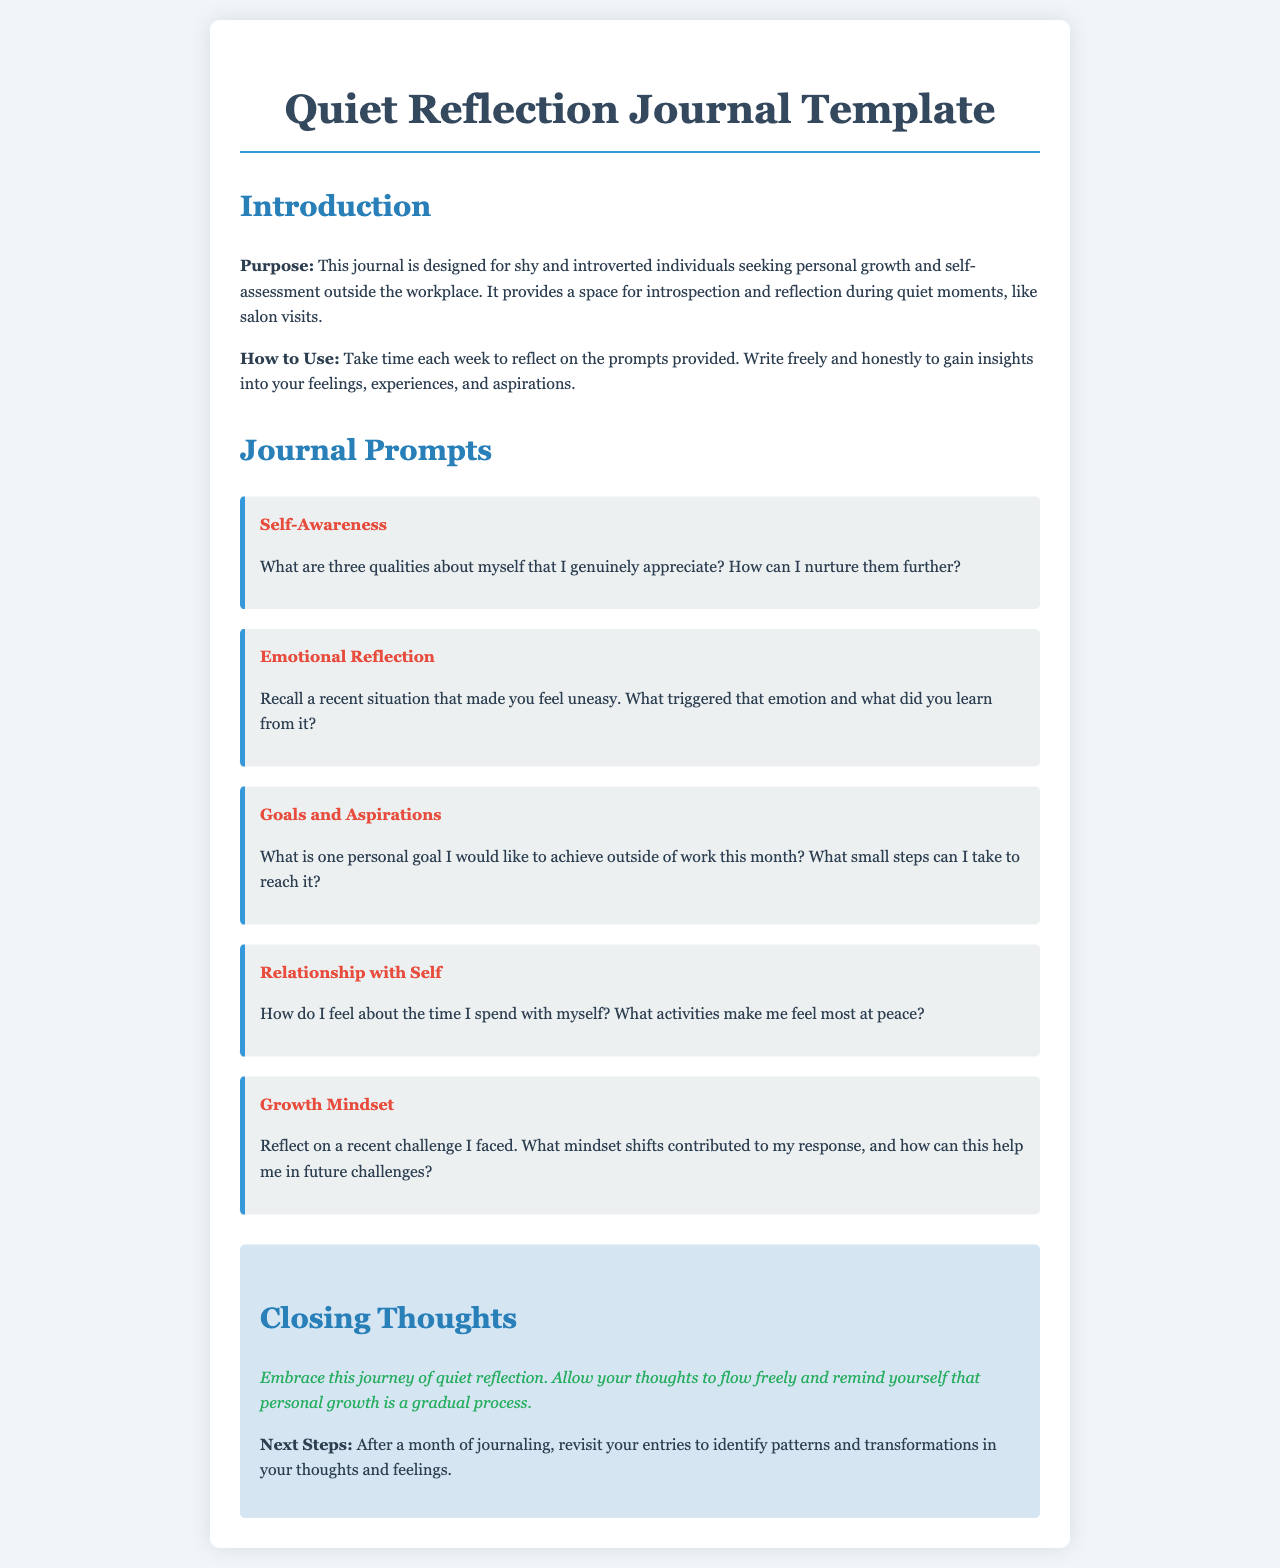What is the title of the document? The title of the document is the main heading found at the top of the page.
Answer: Quiet Reflection Journal Template What is one of the purposes of the journal? The purpose is stated in the introduction section, highlighting the target audience and intent.
Answer: Personal growth How many journal prompts are provided? The number of prompts can be counted by examining the number of categories listed.
Answer: Five What prompt relates to self-awareness? The self-awareness prompt is listed under the overall journal prompts section.
Answer: What are three qualities about myself that I genuinely appreciate? How can I nurture them further? What is the encouragement message at the end? The encouragement message reflects a positive affirmation related to the journaling process found in the closing section.
Answer: Embrace this journey of quiet reflection What is suggested as a next step after a month of journaling? The next steps are indicated in the closing section, suggesting an action post journaling period.
Answer: Revisit your entries What does the "Growth Mindset" prompt ask about? This prompt integrates insights about handling challenges and is indicated in the journal prompts section.
Answer: Reflect on a recent challenge I faced What background color is used in the document? This can be inferred from the styling section that specifies the body background color.
Answer: Light blue 